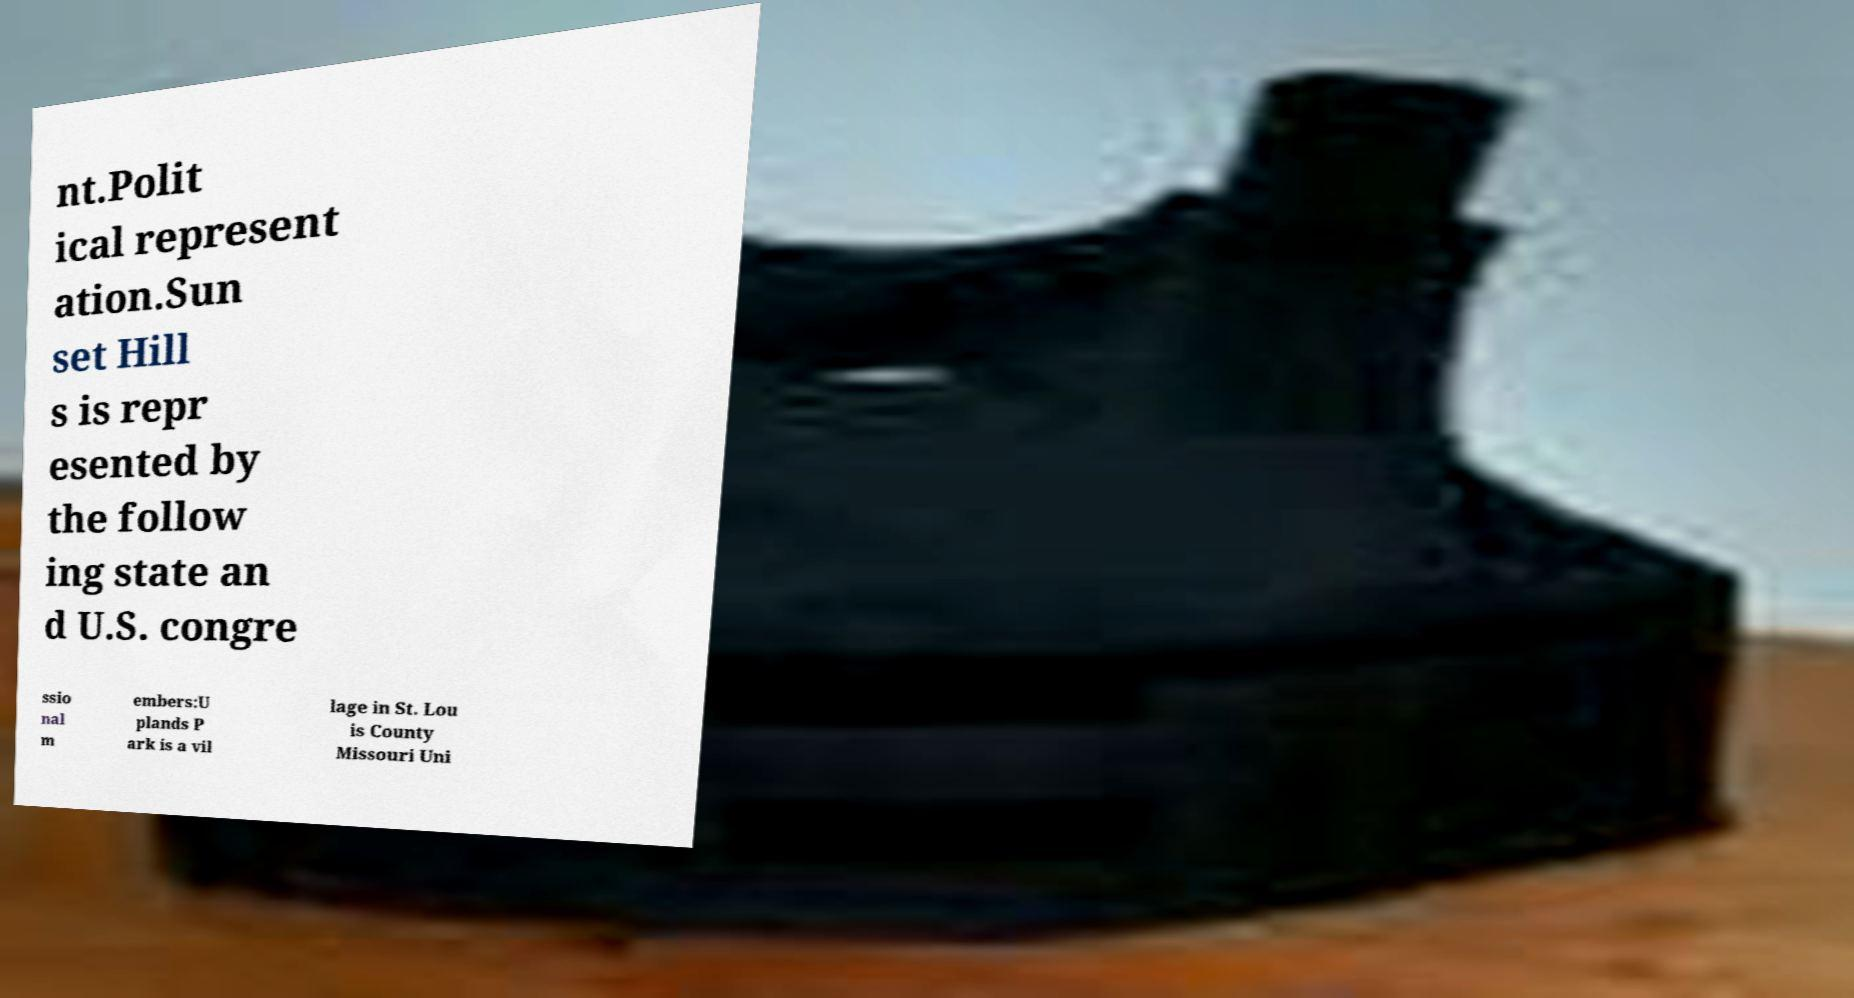Can you read and provide the text displayed in the image?This photo seems to have some interesting text. Can you extract and type it out for me? nt.Polit ical represent ation.Sun set Hill s is repr esented by the follow ing state an d U.S. congre ssio nal m embers:U plands P ark is a vil lage in St. Lou is County Missouri Uni 